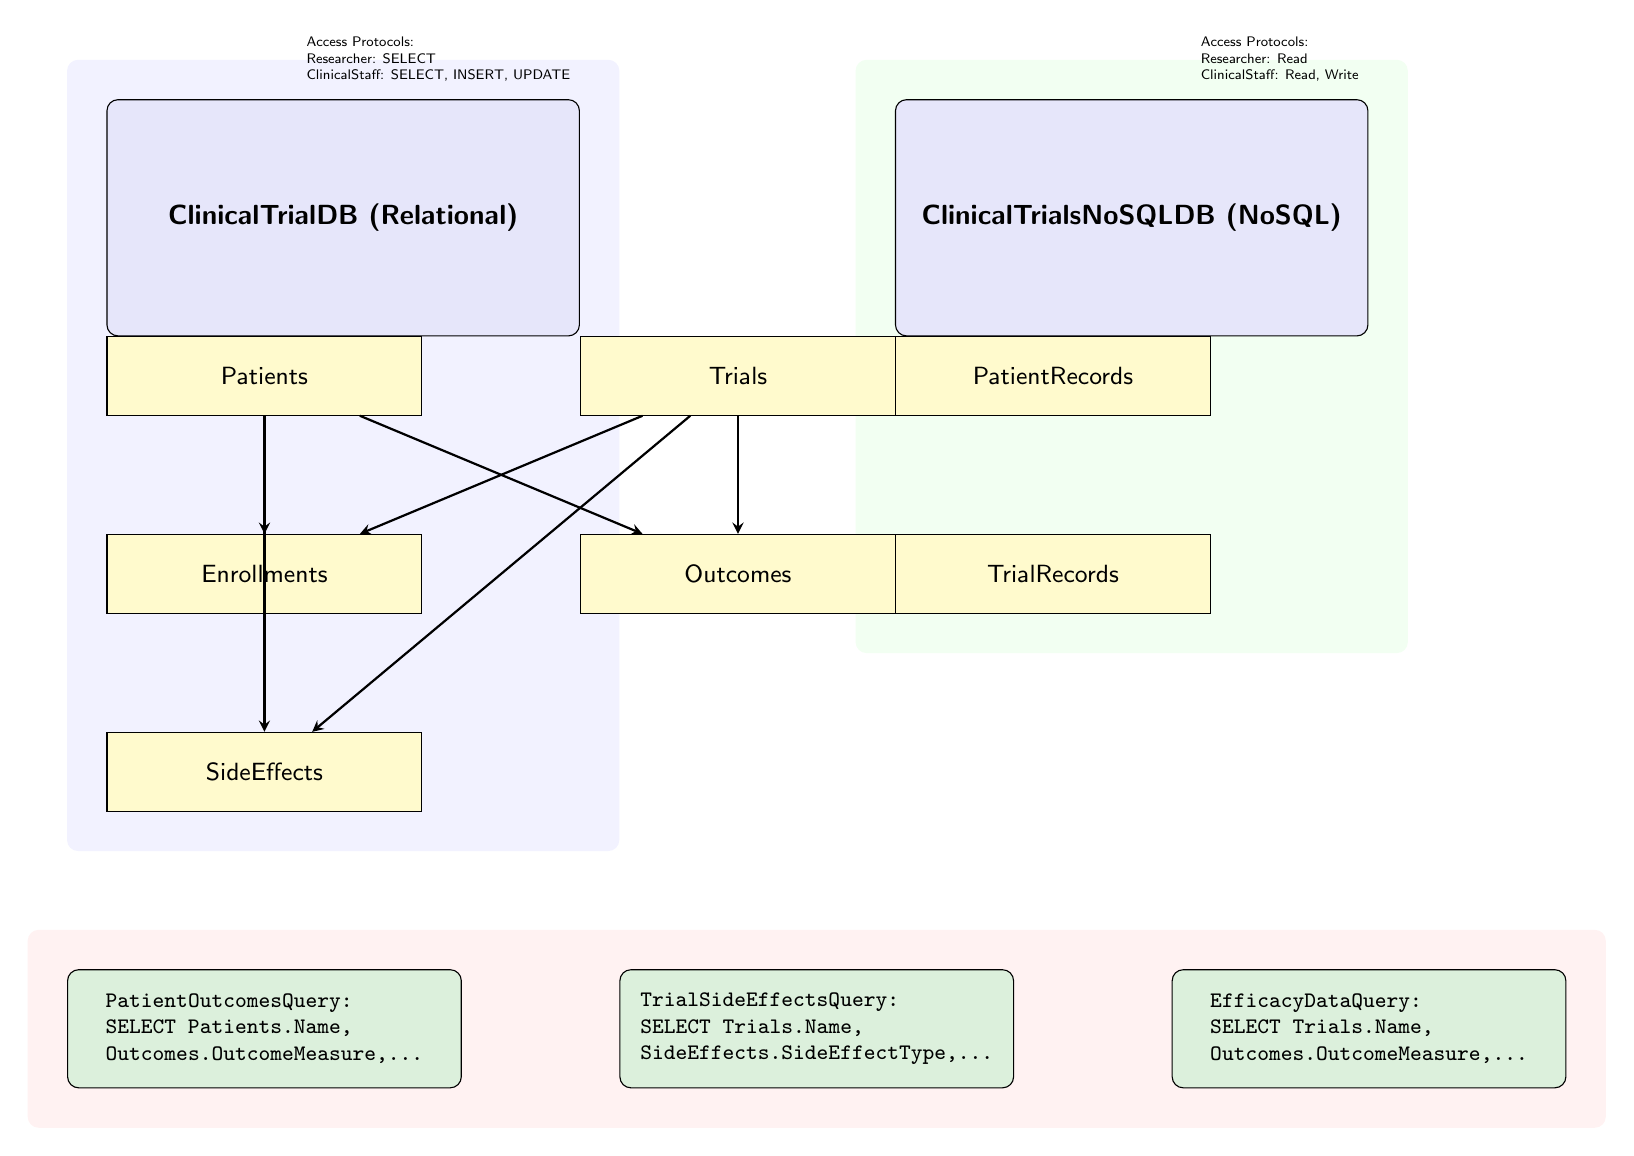What type of database is ClinicalTrialDB? The diagram labels ClinicalTrialDB as a Relational database, indicated by the node type and name.
Answer: Relational How many tables are there in ClinicalTrialDB? The diagram shows five tables connected to ClinicalTrialDB: Patients, Trials, Enrollments, Outcomes, and SideEffects, making it a total of five tables.
Answer: Five What table is directly connected to the Outcomes table? The diagram shows that the Outcomes table has a direct connection from both the Patients table and the Trials table, indicating their relationship.
Answer: Trials What is the purpose of the query labeled PatientOutcomesQuery? The PatientOutcomesQuery is used to select patient names along with their outcome measures, indicating its function is to retrieve patient outcome data.
Answer: Patient outcomes What access protocol does Clinical Staff have for ClinicalTrialsNoSQLDB? The diagram specifies that Clinical Staff has both read and write permissions for the ClinicalTrialsNoSQLDB, as indicated in the access protocols section.
Answer: Read, Write Which table connects patients to enrollments? According to the diagram, the Patients table connects to the Enrollments table, indicating their relationship in the database structure.
Answer: Patients How many queries are represented in the diagram? The diagram displays three different queries: PatientOutcomesQuery, TrialSideEffectsQuery, and EfficacyDataQuery, indicating the total count.
Answer: Three What is the main focus of the TrialSideEffectsQuery? The TrialSideEffectsQuery is designed to retrieve data about the side effects associated with trials, focusing on how trials affect patient safety.
Answer: Side effects In the diagram, which database type is specified as NoSQL? The diagram identifies ClinicalTrialsNoSQLDB as a NoSQL database through its labeling, distinguishing it from the relational database.
Answer: NoSQL 